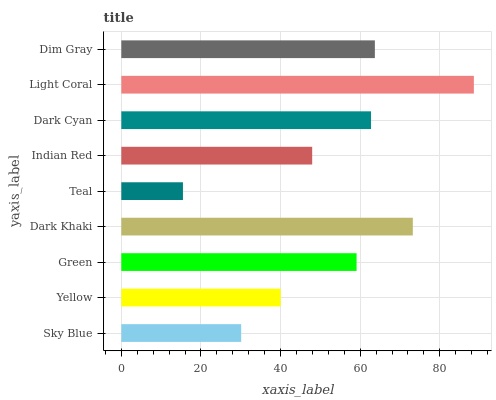Is Teal the minimum?
Answer yes or no. Yes. Is Light Coral the maximum?
Answer yes or no. Yes. Is Yellow the minimum?
Answer yes or no. No. Is Yellow the maximum?
Answer yes or no. No. Is Yellow greater than Sky Blue?
Answer yes or no. Yes. Is Sky Blue less than Yellow?
Answer yes or no. Yes. Is Sky Blue greater than Yellow?
Answer yes or no. No. Is Yellow less than Sky Blue?
Answer yes or no. No. Is Green the high median?
Answer yes or no. Yes. Is Green the low median?
Answer yes or no. Yes. Is Dim Gray the high median?
Answer yes or no. No. Is Teal the low median?
Answer yes or no. No. 